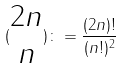Convert formula to latex. <formula><loc_0><loc_0><loc_500><loc_500>( \begin{matrix} 2 n \\ n \end{matrix} ) \colon = \frac { ( 2 n ) ! } { ( n ! ) ^ { 2 } }</formula> 